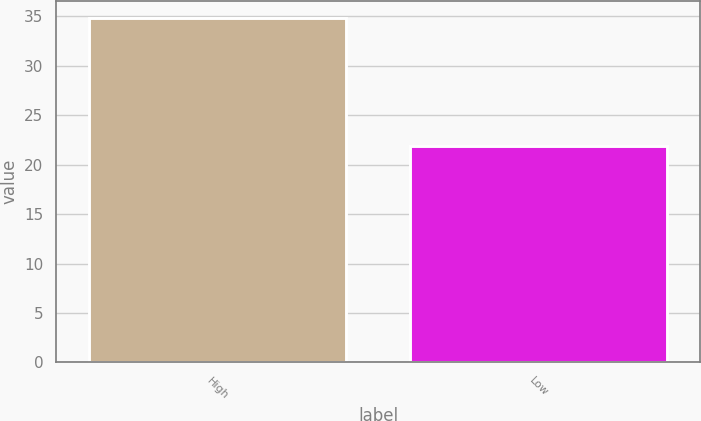Convert chart to OTSL. <chart><loc_0><loc_0><loc_500><loc_500><bar_chart><fcel>High<fcel>Low<nl><fcel>34.8<fcel>21.91<nl></chart> 